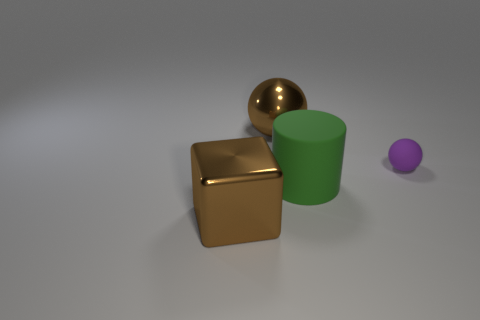What is the material of the big block that is the same color as the big sphere?
Offer a terse response. Metal. Are there an equal number of small purple balls that are on the left side of the large rubber cylinder and big green matte things?
Offer a terse response. No. There is a ball in front of the brown shiny sphere; how big is it?
Provide a short and direct response. Small. How many other metal things have the same shape as the purple thing?
Provide a succinct answer. 1. There is a thing that is both right of the shiny ball and in front of the tiny rubber sphere; what material is it?
Your answer should be compact. Rubber. Do the small purple object and the cube have the same material?
Your answer should be compact. No. How many tiny metallic things are there?
Offer a very short reply. 0. There is a big shiny thing that is behind the large brown thing that is in front of the metallic object that is on the right side of the brown metallic block; what is its color?
Keep it short and to the point. Brown. Do the tiny object and the big shiny block have the same color?
Give a very brief answer. No. What number of things are both on the left side of the small purple ball and behind the green matte thing?
Give a very brief answer. 1. 